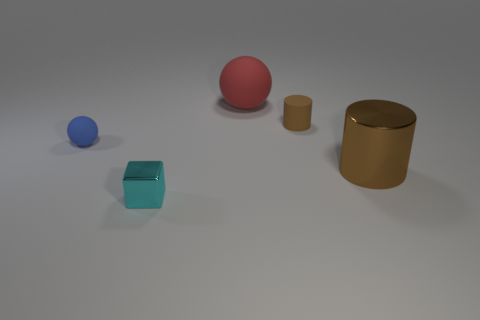Are there more small things left of the cyan block than large blue things?
Ensure brevity in your answer.  Yes. What size is the red thing that is the same material as the tiny blue object?
Keep it short and to the point. Large. Are there any other cylinders of the same color as the matte cylinder?
Your answer should be compact. Yes. What number of things are small cyan blocks or things in front of the big metal thing?
Provide a short and direct response. 1. Is the number of big rubber cylinders greater than the number of tiny rubber spheres?
Your answer should be very brief. No. What is the size of the object that is the same color as the large shiny cylinder?
Provide a short and direct response. Small. Is there a large yellow ball that has the same material as the tiny brown cylinder?
Make the answer very short. No. What shape is the thing that is behind the small ball and in front of the large matte thing?
Provide a succinct answer. Cylinder. How many other things are the same shape as the small blue matte thing?
Offer a very short reply. 1. What is the size of the red ball?
Provide a succinct answer. Large. 